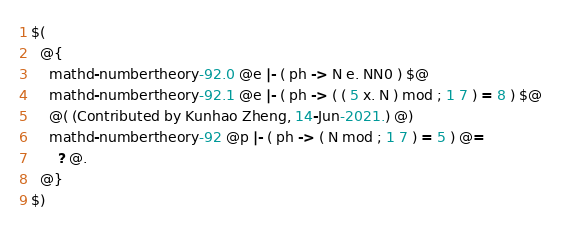<code> <loc_0><loc_0><loc_500><loc_500><_ObjectiveC_>$(
  @{
    mathd-numbertheory-92.0 @e |- ( ph -> N e. NN0 ) $@
    mathd-numbertheory-92.1 @e |- ( ph -> ( ( 5 x. N ) mod ; 1 7 ) = 8 ) $@
    @( (Contributed by Kunhao Zheng, 14-Jun-2021.) @)
    mathd-numbertheory-92 @p |- ( ph -> ( N mod ; 1 7 ) = 5 ) @=
      ? @.
  @}
$)
</code> 